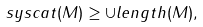Convert formula to latex. <formula><loc_0><loc_0><loc_500><loc_500>\ s y s c a t ( M ) \geq \cup l e n g t h ( M ) ,</formula> 